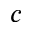<formula> <loc_0><loc_0><loc_500><loc_500>c</formula> 